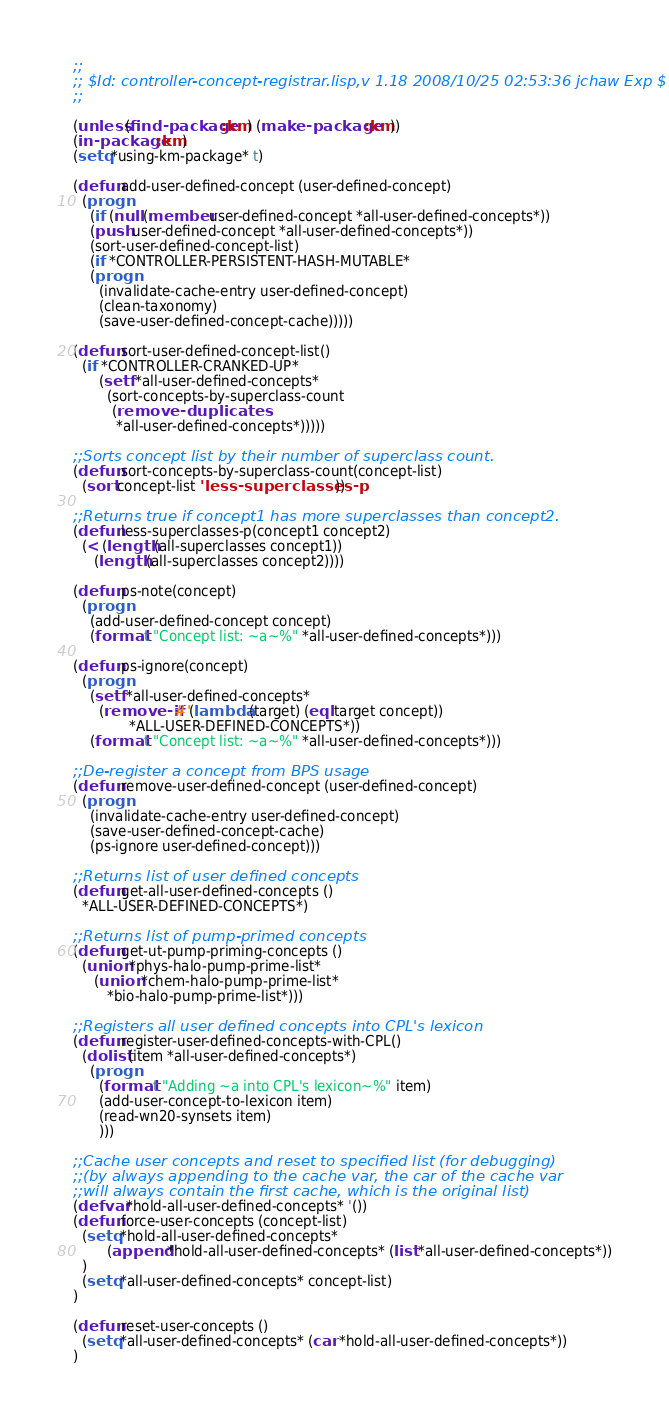<code> <loc_0><loc_0><loc_500><loc_500><_Lisp_>;;
;; $Id: controller-concept-registrar.lisp,v 1.18 2008/10/25 02:53:36 jchaw Exp $
;;

(unless (find-package :km) (make-package :km))
(in-package :km)
(setq *using-km-package* t)

(defun add-user-defined-concept (user-defined-concept)
  (progn
    (if (null (member user-defined-concept *all-user-defined-concepts*))
	(push user-defined-concept *all-user-defined-concepts*))
    (sort-user-defined-concept-list)
    (if *CONTROLLER-PERSISTENT-HASH-MUTABLE*
	(progn 
	  (invalidate-cache-entry user-defined-concept)
	  (clean-taxonomy)
	  (save-user-defined-concept-cache)))))

(defun sort-user-defined-concept-list()
  (if *CONTROLLER-CRANKED-UP*
      (setf *all-user-defined-concepts* 
	    (sort-concepts-by-superclass-count
	     (remove-duplicates 
	      *all-user-defined-concepts*)))))

;;Sorts concept list by their number of superclass count.
(defun sort-concepts-by-superclass-count(concept-list)
  (sort concept-list 'less-superclasses-p))

;;Returns true if concept1 has more superclasses than concept2.
(defun less-superclasses-p(concept1 concept2)
  (< (length (all-superclasses concept1))
     (length (all-superclasses concept2))))

(defun ps-note(concept)
  (progn 
    (add-user-defined-concept concept)
    (format t "Concept list: ~a~%" *all-user-defined-concepts*)))

(defun ps-ignore(concept)
  (progn 
    (setf *all-user-defined-concepts*
	  (remove-if #'(lambda (target) (eql target concept))
		     *ALL-USER-DEFINED-CONCEPTS*))
    (format t "Concept list: ~a~%" *all-user-defined-concepts*)))

;;De-register a concept from BPS usage
(defun remove-user-defined-concept (user-defined-concept)
  (progn 
    (invalidate-cache-entry user-defined-concept)
    (save-user-defined-concept-cache)
    (ps-ignore user-defined-concept)))

;;Returns list of user defined concepts
(defun get-all-user-defined-concepts ()
  *ALL-USER-DEFINED-CONCEPTS*)

;;Returns list of pump-primed concepts
(defun get-ut-pump-priming-concepts ()
  (union *phys-halo-pump-prime-list*
	 (union *chem-halo-pump-prime-list*
		*bio-halo-pump-prime-list*)))

;;Registers all user defined concepts into CPL's lexicon
(defun register-user-defined-concepts-with-CPL()
  (dolist (item *all-user-defined-concepts*)
    (progn
      (format t "Adding ~a into CPL's lexicon~%" item)
      (add-user-concept-to-lexicon item)
      (read-wn20-synsets item)
      )))

;;Cache user concepts and reset to specified list (for debugging)
;;(by always appending to the cache var, the car of the cache var
;;will always contain the first cache, which is the original list)
(defvar *hold-all-user-defined-concepts* '())
(defun force-user-concepts (concept-list)
  (setq *hold-all-user-defined-concepts* 
        (append *hold-all-user-defined-concepts* (list *all-user-defined-concepts*))
  )
  (setq *all-user-defined-concepts* concept-list)
)

(defun reset-user-concepts ()
  (setq *all-user-defined-concepts* (car *hold-all-user-defined-concepts*))
)


</code> 